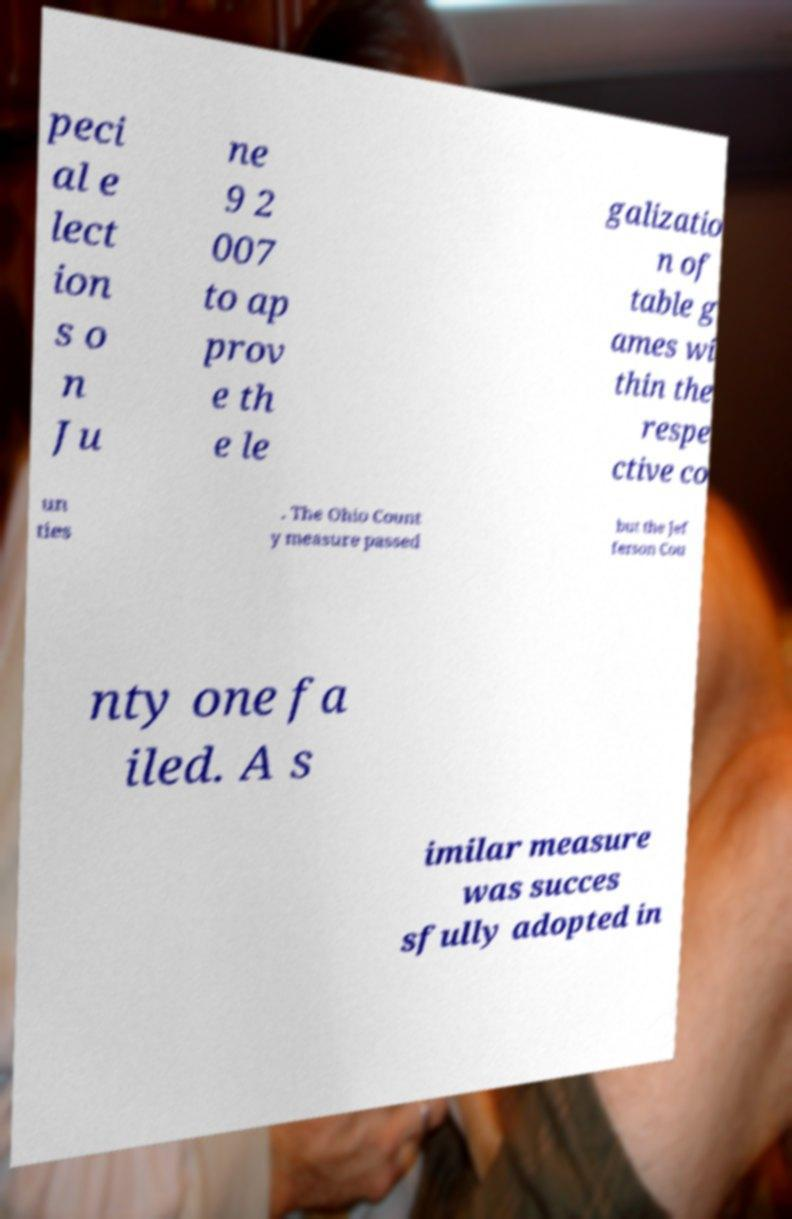Please identify and transcribe the text found in this image. peci al e lect ion s o n Ju ne 9 2 007 to ap prov e th e le galizatio n of table g ames wi thin the respe ctive co un ties . The Ohio Count y measure passed but the Jef ferson Cou nty one fa iled. A s imilar measure was succes sfully adopted in 